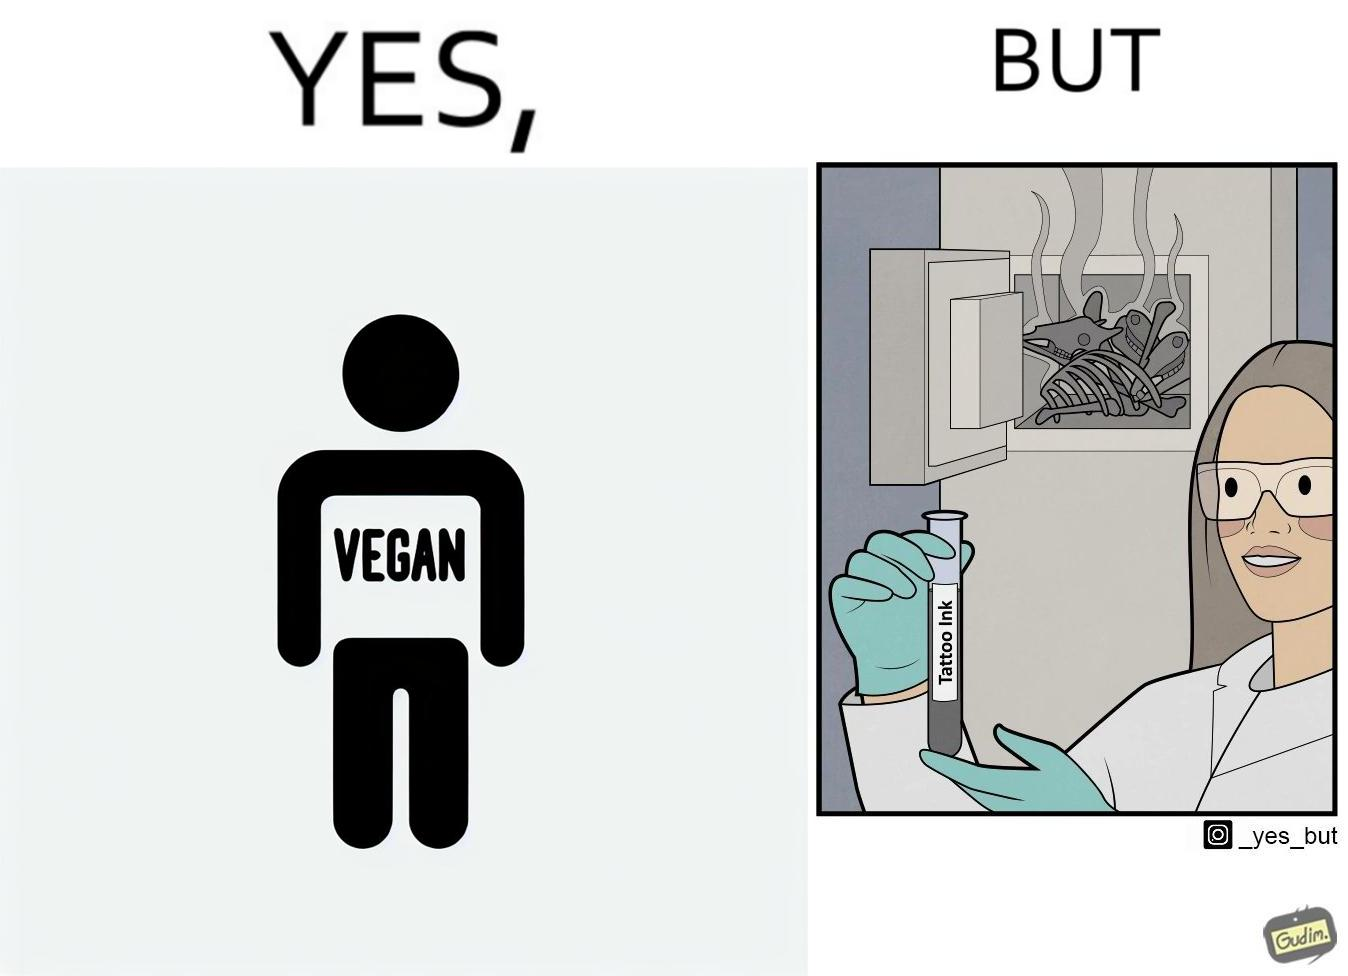Compare the left and right sides of this image. In the left part of the image: Image of a person's tattoo that says 'vegan' In the right part of the image: Image of a scientist making tattoo ink using animal bones. 